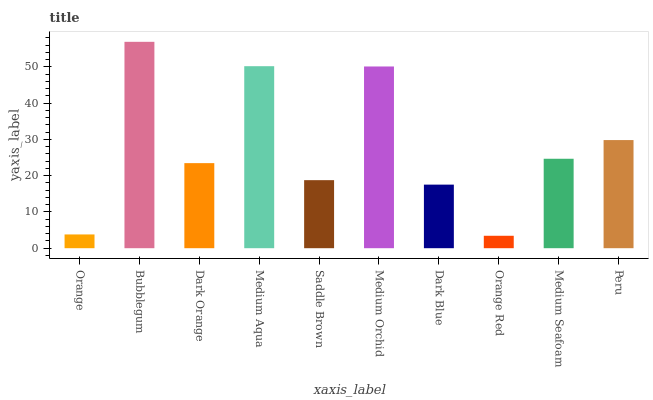Is Orange Red the minimum?
Answer yes or no. Yes. Is Bubblegum the maximum?
Answer yes or no. Yes. Is Dark Orange the minimum?
Answer yes or no. No. Is Dark Orange the maximum?
Answer yes or no. No. Is Bubblegum greater than Dark Orange?
Answer yes or no. Yes. Is Dark Orange less than Bubblegum?
Answer yes or no. Yes. Is Dark Orange greater than Bubblegum?
Answer yes or no. No. Is Bubblegum less than Dark Orange?
Answer yes or no. No. Is Medium Seafoam the high median?
Answer yes or no. Yes. Is Dark Orange the low median?
Answer yes or no. Yes. Is Dark Orange the high median?
Answer yes or no. No. Is Dark Blue the low median?
Answer yes or no. No. 